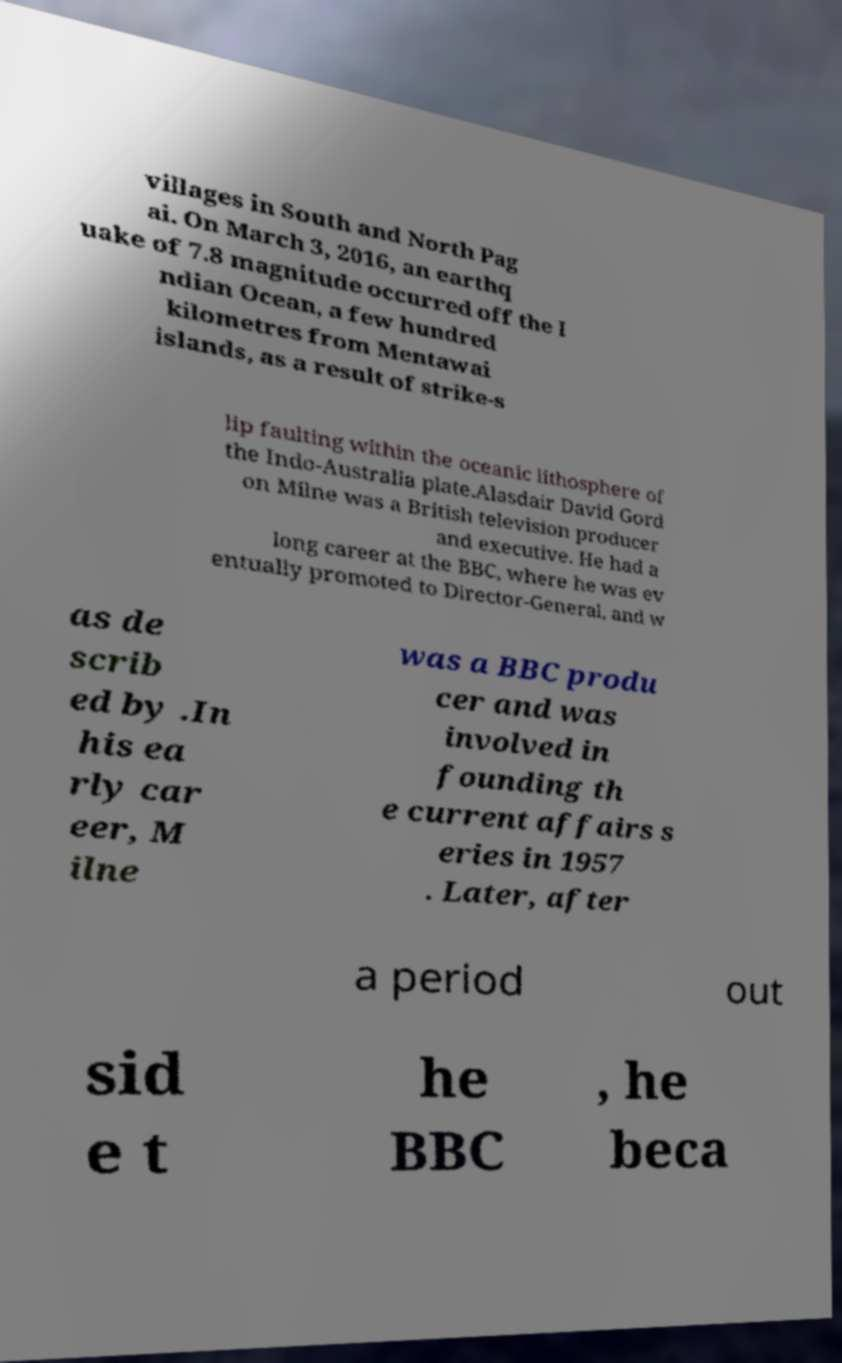Could you extract and type out the text from this image? villages in South and North Pag ai. On March 3, 2016, an earthq uake of 7.8 magnitude occurred off the I ndian Ocean, a few hundred kilometres from Mentawai islands, as a result of strike-s lip faulting within the oceanic lithosphere of the Indo-Australia plate.Alasdair David Gord on Milne was a British television producer and executive. He had a long career at the BBC, where he was ev entually promoted to Director-General, and w as de scrib ed by .In his ea rly car eer, M ilne was a BBC produ cer and was involved in founding th e current affairs s eries in 1957 . Later, after a period out sid e t he BBC , he beca 